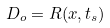Convert formula to latex. <formula><loc_0><loc_0><loc_500><loc_500>D _ { o } = R ( x , t _ { s } )</formula> 